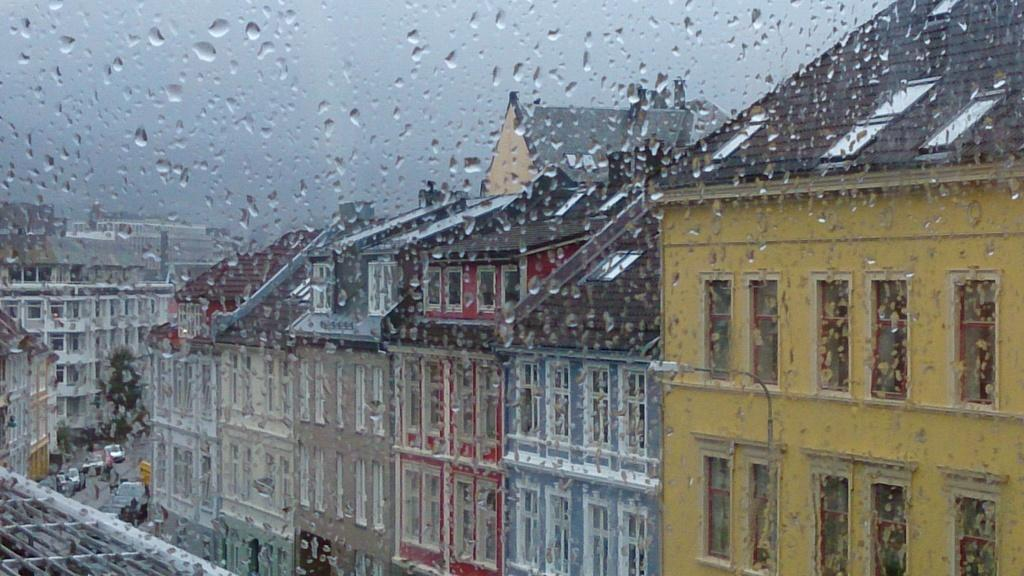What is in the glass that is visible in the image? There is water in the glass. What can be seen through the glass in the image? Buildings, trees, vehicles, and the sky are visible through the glass. What type of bomb can be seen in the image? There is no bomb present in the image. Is the image set during the night? The provided facts do not mention the time of day, so it cannot be determined if the image is set during the night. 